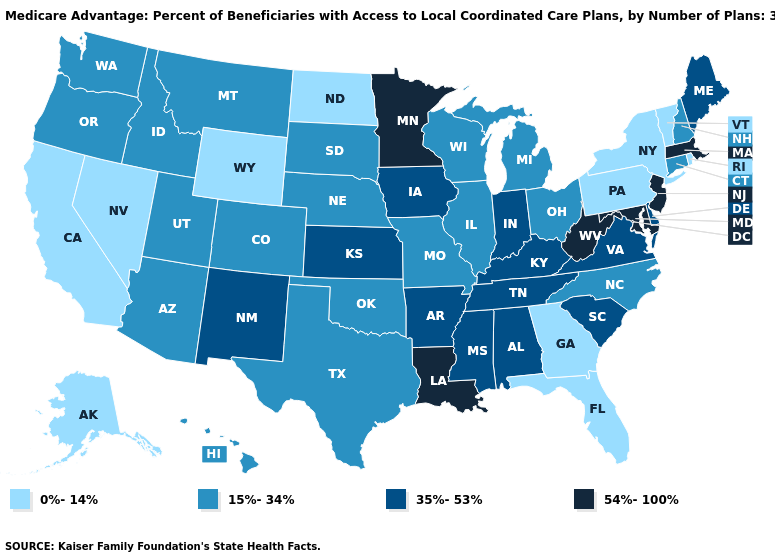What is the value of Washington?
Short answer required. 15%-34%. Does Oregon have the lowest value in the USA?
Answer briefly. No. Which states have the lowest value in the USA?
Answer briefly. Alaska, California, Florida, Georgia, North Dakota, Nevada, New York, Pennsylvania, Rhode Island, Vermont, Wyoming. Name the states that have a value in the range 35%-53%?
Concise answer only. Alabama, Arkansas, Delaware, Iowa, Indiana, Kansas, Kentucky, Maine, Mississippi, New Mexico, South Carolina, Tennessee, Virginia. Does Louisiana have the highest value in the USA?
Give a very brief answer. Yes. What is the value of Iowa?
Answer briefly. 35%-53%. What is the value of Missouri?
Give a very brief answer. 15%-34%. Name the states that have a value in the range 0%-14%?
Be succinct. Alaska, California, Florida, Georgia, North Dakota, Nevada, New York, Pennsylvania, Rhode Island, Vermont, Wyoming. Does New Jersey have the highest value in the USA?
Answer briefly. Yes. What is the lowest value in states that border Rhode Island?
Be succinct. 15%-34%. What is the value of Kentucky?
Give a very brief answer. 35%-53%. Does the map have missing data?
Short answer required. No. Which states have the lowest value in the USA?
Quick response, please. Alaska, California, Florida, Georgia, North Dakota, Nevada, New York, Pennsylvania, Rhode Island, Vermont, Wyoming. Does the first symbol in the legend represent the smallest category?
Concise answer only. Yes. Is the legend a continuous bar?
Answer briefly. No. 